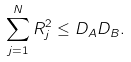<formula> <loc_0><loc_0><loc_500><loc_500>\sum _ { j = 1 } ^ { N } R _ { j } ^ { 2 } \leq D _ { A } D _ { B } .</formula> 